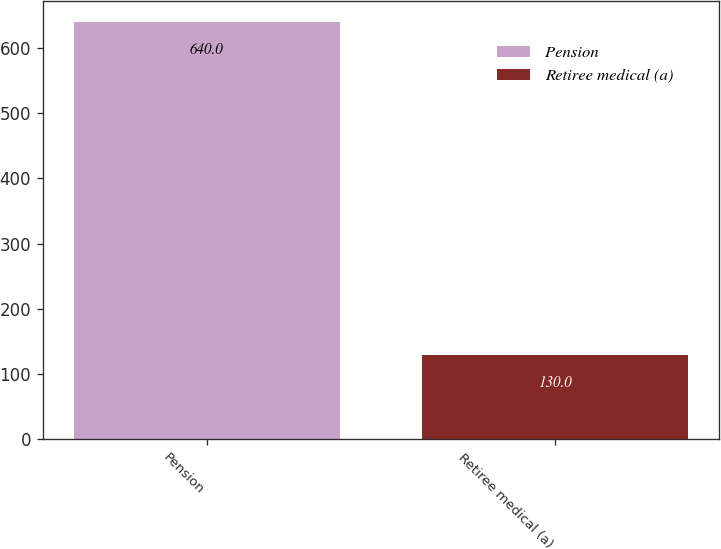Convert chart. <chart><loc_0><loc_0><loc_500><loc_500><bar_chart><fcel>Pension<fcel>Retiree medical (a)<nl><fcel>640<fcel>130<nl></chart> 